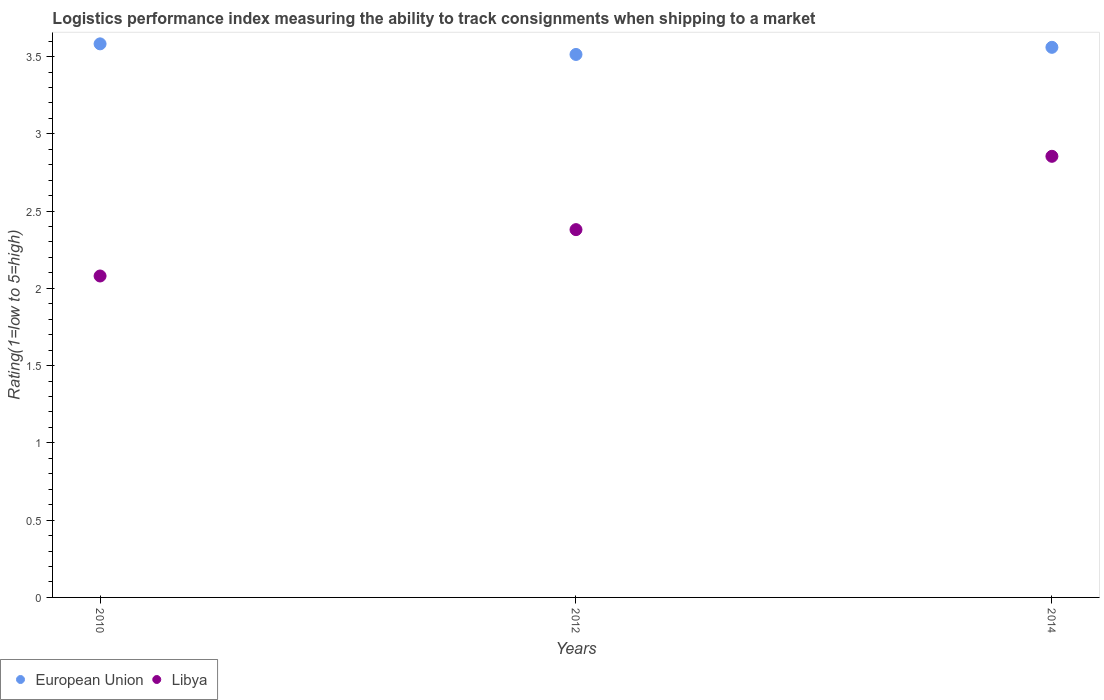Is the number of dotlines equal to the number of legend labels?
Ensure brevity in your answer.  Yes. What is the Logistic performance index in European Union in 2014?
Give a very brief answer. 3.56. Across all years, what is the maximum Logistic performance index in Libya?
Offer a very short reply. 2.85. Across all years, what is the minimum Logistic performance index in European Union?
Provide a succinct answer. 3.51. What is the total Logistic performance index in European Union in the graph?
Your answer should be compact. 10.66. What is the difference between the Logistic performance index in European Union in 2012 and that in 2014?
Your answer should be compact. -0.05. What is the difference between the Logistic performance index in European Union in 2012 and the Logistic performance index in Libya in 2010?
Make the answer very short. 1.43. What is the average Logistic performance index in European Union per year?
Your answer should be compact. 3.55. In the year 2012, what is the difference between the Logistic performance index in European Union and Logistic performance index in Libya?
Give a very brief answer. 1.13. In how many years, is the Logistic performance index in European Union greater than 0.2?
Your answer should be very brief. 3. What is the ratio of the Logistic performance index in Libya in 2010 to that in 2012?
Provide a short and direct response. 0.87. Is the Logistic performance index in Libya in 2010 less than that in 2014?
Offer a terse response. Yes. What is the difference between the highest and the second highest Logistic performance index in European Union?
Keep it short and to the point. 0.02. What is the difference between the highest and the lowest Logistic performance index in Libya?
Your answer should be compact. 0.77. In how many years, is the Logistic performance index in European Union greater than the average Logistic performance index in European Union taken over all years?
Offer a very short reply. 2. Is the sum of the Logistic performance index in European Union in 2012 and 2014 greater than the maximum Logistic performance index in Libya across all years?
Give a very brief answer. Yes. Does the Logistic performance index in European Union monotonically increase over the years?
Provide a succinct answer. No. Is the Logistic performance index in European Union strictly less than the Logistic performance index in Libya over the years?
Your answer should be very brief. No. How many dotlines are there?
Offer a very short reply. 2. How many years are there in the graph?
Provide a succinct answer. 3. What is the difference between two consecutive major ticks on the Y-axis?
Give a very brief answer. 0.5. Are the values on the major ticks of Y-axis written in scientific E-notation?
Give a very brief answer. No. Does the graph contain any zero values?
Provide a succinct answer. No. Does the graph contain grids?
Provide a short and direct response. No. How many legend labels are there?
Give a very brief answer. 2. How are the legend labels stacked?
Provide a succinct answer. Horizontal. What is the title of the graph?
Ensure brevity in your answer.  Logistics performance index measuring the ability to track consignments when shipping to a market. What is the label or title of the X-axis?
Give a very brief answer. Years. What is the label or title of the Y-axis?
Your answer should be compact. Rating(1=low to 5=high). What is the Rating(1=low to 5=high) of European Union in 2010?
Offer a terse response. 3.58. What is the Rating(1=low to 5=high) of Libya in 2010?
Provide a succinct answer. 2.08. What is the Rating(1=low to 5=high) in European Union in 2012?
Offer a very short reply. 3.51. What is the Rating(1=low to 5=high) in Libya in 2012?
Provide a short and direct response. 2.38. What is the Rating(1=low to 5=high) in European Union in 2014?
Your response must be concise. 3.56. What is the Rating(1=low to 5=high) in Libya in 2014?
Ensure brevity in your answer.  2.85. Across all years, what is the maximum Rating(1=low to 5=high) in European Union?
Your answer should be compact. 3.58. Across all years, what is the maximum Rating(1=low to 5=high) in Libya?
Your response must be concise. 2.85. Across all years, what is the minimum Rating(1=low to 5=high) of European Union?
Make the answer very short. 3.51. Across all years, what is the minimum Rating(1=low to 5=high) of Libya?
Make the answer very short. 2.08. What is the total Rating(1=low to 5=high) of European Union in the graph?
Give a very brief answer. 10.66. What is the total Rating(1=low to 5=high) of Libya in the graph?
Keep it short and to the point. 7.31. What is the difference between the Rating(1=low to 5=high) of European Union in 2010 and that in 2012?
Make the answer very short. 0.07. What is the difference between the Rating(1=low to 5=high) of European Union in 2010 and that in 2014?
Provide a succinct answer. 0.02. What is the difference between the Rating(1=low to 5=high) in Libya in 2010 and that in 2014?
Offer a very short reply. -0.77. What is the difference between the Rating(1=low to 5=high) in European Union in 2012 and that in 2014?
Your answer should be compact. -0.05. What is the difference between the Rating(1=low to 5=high) of Libya in 2012 and that in 2014?
Keep it short and to the point. -0.47. What is the difference between the Rating(1=low to 5=high) in European Union in 2010 and the Rating(1=low to 5=high) in Libya in 2012?
Give a very brief answer. 1.2. What is the difference between the Rating(1=low to 5=high) of European Union in 2010 and the Rating(1=low to 5=high) of Libya in 2014?
Keep it short and to the point. 0.73. What is the difference between the Rating(1=low to 5=high) in European Union in 2012 and the Rating(1=low to 5=high) in Libya in 2014?
Your answer should be compact. 0.66. What is the average Rating(1=low to 5=high) in European Union per year?
Provide a short and direct response. 3.55. What is the average Rating(1=low to 5=high) of Libya per year?
Your answer should be compact. 2.44. In the year 2010, what is the difference between the Rating(1=low to 5=high) in European Union and Rating(1=low to 5=high) in Libya?
Provide a succinct answer. 1.5. In the year 2012, what is the difference between the Rating(1=low to 5=high) of European Union and Rating(1=low to 5=high) of Libya?
Make the answer very short. 1.13. In the year 2014, what is the difference between the Rating(1=low to 5=high) in European Union and Rating(1=low to 5=high) in Libya?
Make the answer very short. 0.71. What is the ratio of the Rating(1=low to 5=high) of European Union in 2010 to that in 2012?
Make the answer very short. 1.02. What is the ratio of the Rating(1=low to 5=high) in Libya in 2010 to that in 2012?
Offer a terse response. 0.87. What is the ratio of the Rating(1=low to 5=high) of Libya in 2010 to that in 2014?
Keep it short and to the point. 0.73. What is the ratio of the Rating(1=low to 5=high) of Libya in 2012 to that in 2014?
Provide a succinct answer. 0.83. What is the difference between the highest and the second highest Rating(1=low to 5=high) in European Union?
Your response must be concise. 0.02. What is the difference between the highest and the second highest Rating(1=low to 5=high) of Libya?
Keep it short and to the point. 0.47. What is the difference between the highest and the lowest Rating(1=low to 5=high) in European Union?
Give a very brief answer. 0.07. What is the difference between the highest and the lowest Rating(1=low to 5=high) in Libya?
Your answer should be very brief. 0.77. 